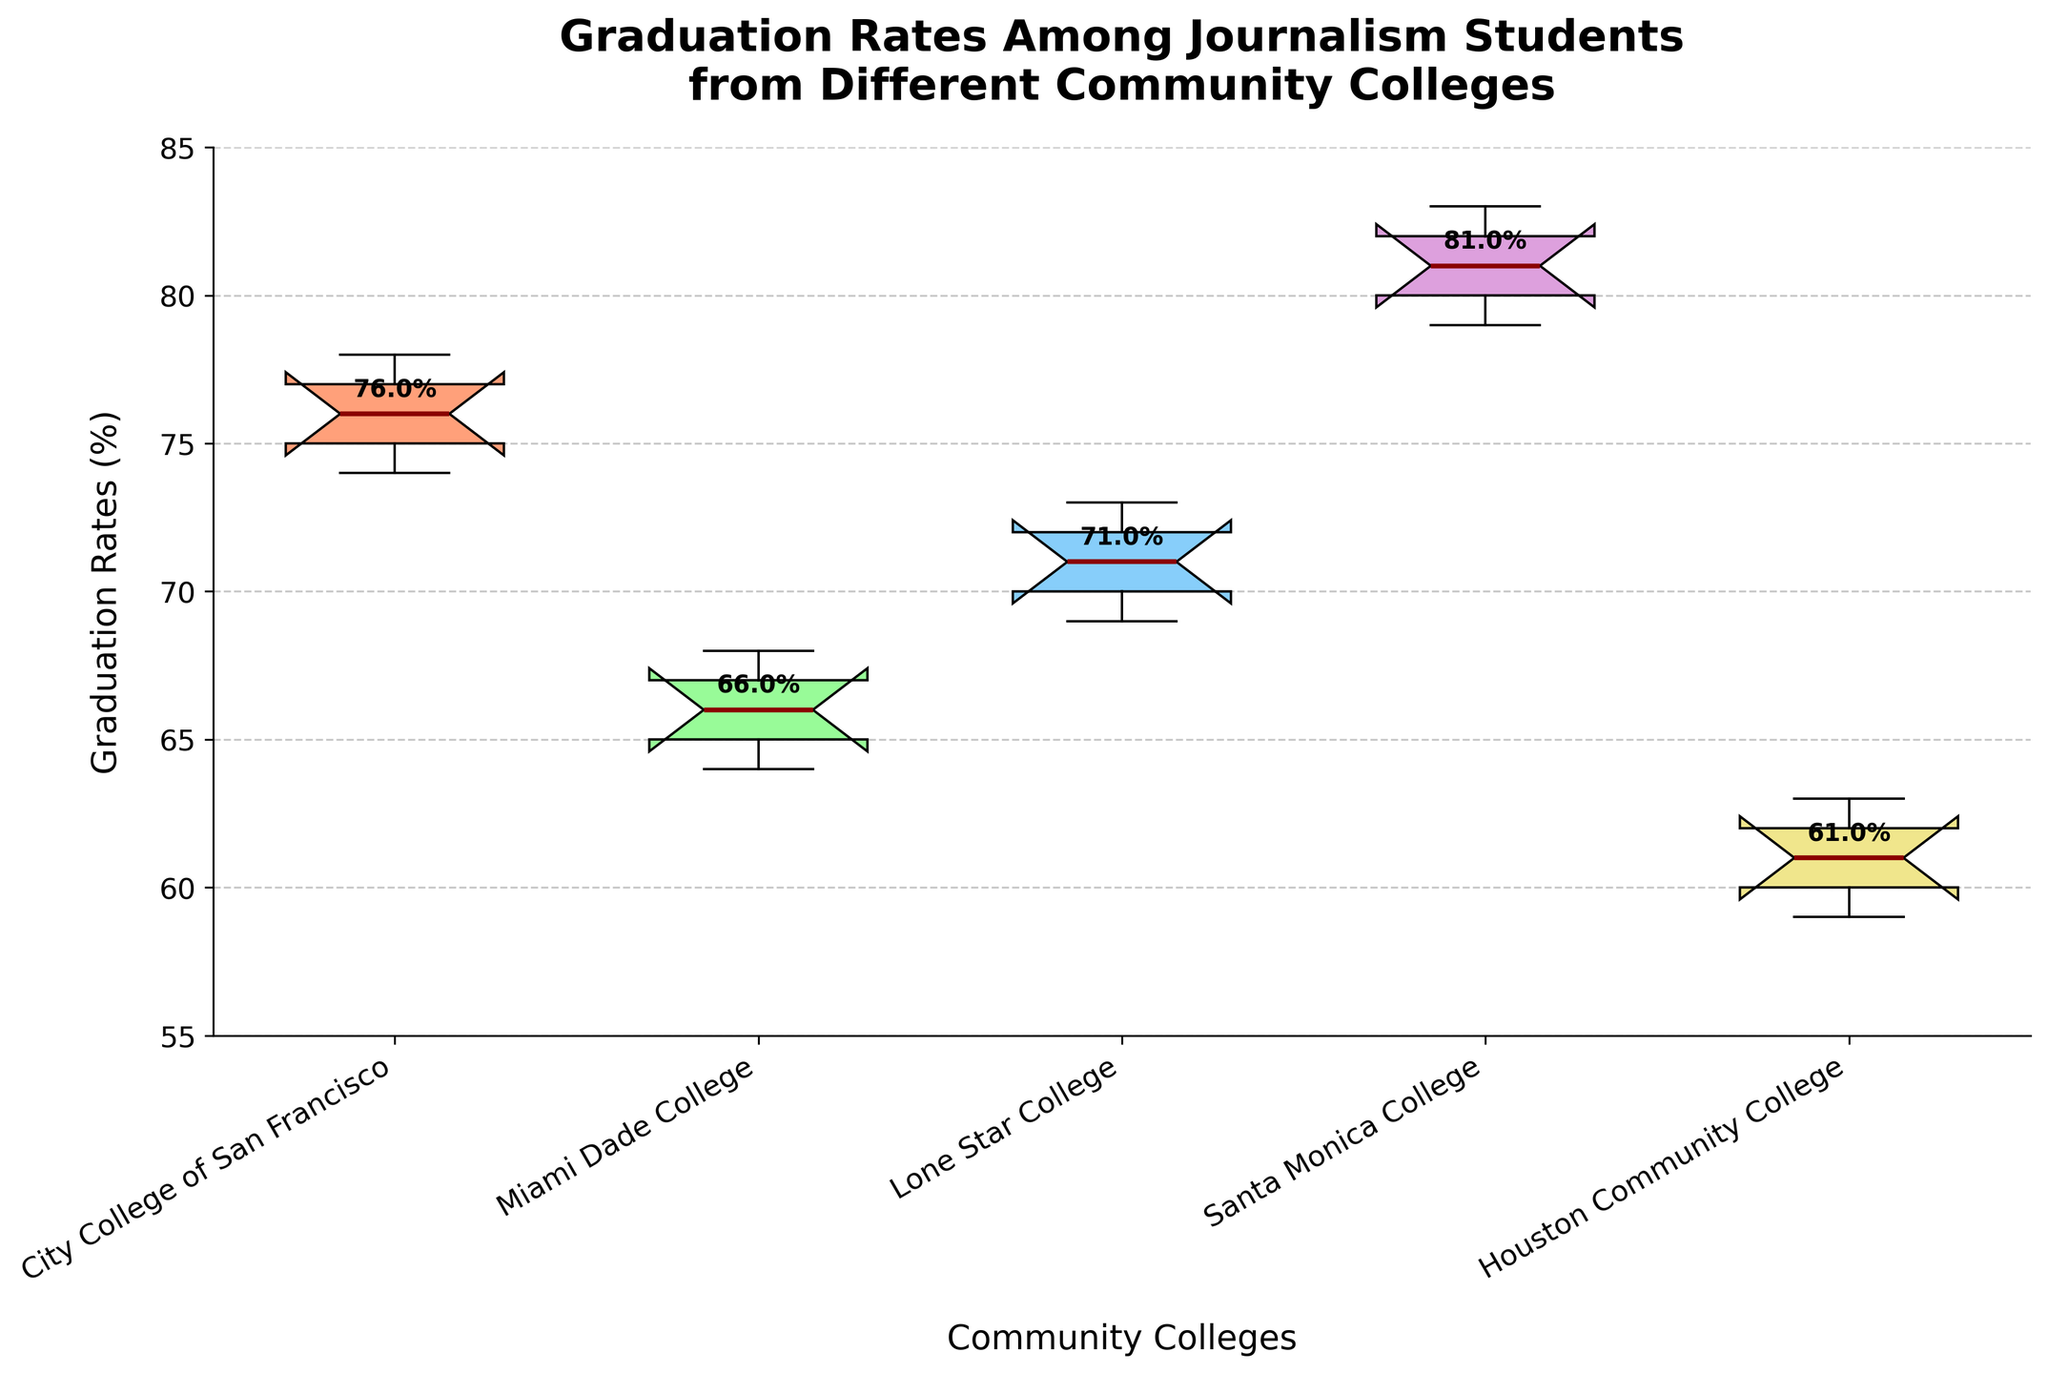What's the title of the figure? The title is displayed at the top of the figure, summarizing the content and purpose. It reads, "Graduation Rates Among Journalism Students from Different Community Colleges."
Answer: Graduation Rates Among Journalism Students from Different Community Colleges Which college has the highest median graduation rate? The median graduation rate for each college is marked by a dark red line within each box plot. Santa Monica College has the highest median line among all colleges.
Answer: Santa Monica College What is the interquartile range (IQR) for Miami Dade College? The IQR is represented by the length of the box. It stretches from the 25th percentile (bottom of the box) to the 75th percentile (top of the box). For Miami Dade College, the 25th percentile is 64%, and the 75th percentile is 67%. Therefore, the IQR is 67% - 64%.
Answer: 3% Which college shows the greatest variation in graduation rates? Variation in graduation rates is indicated by the length of the whiskers and the presence of outliers. Miami Dade College exhibits wider whiskers and more outliers, suggesting greater variation.
Answer: Miami Dade College How does the graduation rate of Lone Star College compare to Houston Community College? Comparing the medians, Lone Star College has a higher median graduation rate than Houston Community College. The box plot for Lone Star College is also situated higher on the scale.
Answer: Lone Star College has a higher median graduation rate than Houston Community College What's the range of graduation rates for Santa Monica College? The range can be calculated by subtracting the minimum value (bottom whisker) from the maximum value (top whisker). For Santa Monica College, the lower whisker is at 79% and the upper whisker is at 83%, making the range 83% - 79%.
Answer: 4% Describe the distribution of graduation rates for City College of San Francisco. The box plot for City College of San Francisco shows that the median is close to the middle of the box, with fairly symmetric whiskers and no noticeable outliers. This suggests a fairly normal distribution.
Answer: Normal distribution Which college has the narrowest interquartile range (IQR)? The college with the narrowest box has the smallest IQR. For these colleges, Houston Community College has the narrowest IQR since the box is the smallest.
Answer: Houston Community College Are there any outliers for Houston Community College? Outliers are marked by distinct markers outside the whiskers. In the box plot for Houston Community College, no such markers are present, indicating no outliers.
Answer: No What can you infer from the notches in the box plots? Notches indicate the confidence interval around the median. If the notches of two boxes do not overlap, it suggests that the medians are statistically significantly different. Examining the notches, Santa Monica College's notches do not overlap with others, suggesting that its median graduation rate is significantly different.
Answer: Santa Monica College has a significantly different median 